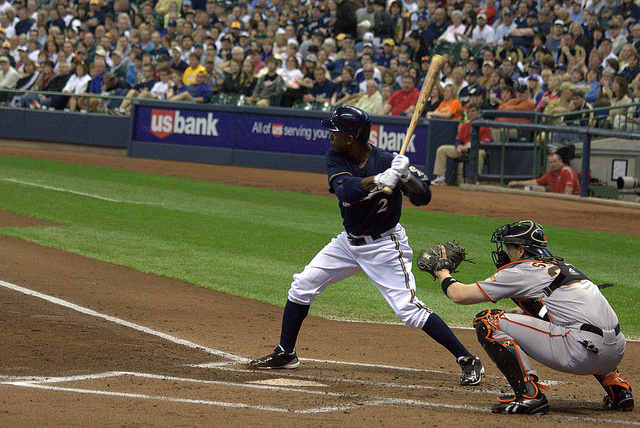Identify and read out the text in this image. 2 US bank d S sbank you services 